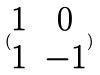Convert formula to latex. <formula><loc_0><loc_0><loc_500><loc_500>( \begin{matrix} 1 & 0 \\ 1 & - 1 \end{matrix} )</formula> 